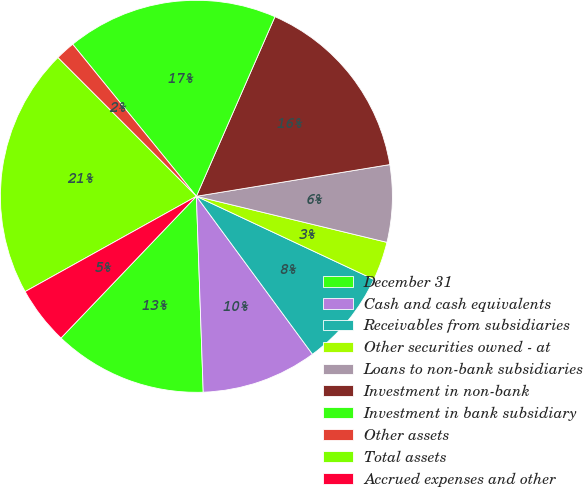Convert chart. <chart><loc_0><loc_0><loc_500><loc_500><pie_chart><fcel>December 31<fcel>Cash and cash equivalents<fcel>Receivables from subsidiaries<fcel>Other securities owned - at<fcel>Loans to non-bank subsidiaries<fcel>Investment in non-bank<fcel>Investment in bank subsidiary<fcel>Other assets<fcel>Total assets<fcel>Accrued expenses and other<nl><fcel>12.69%<fcel>9.53%<fcel>7.94%<fcel>3.2%<fcel>6.36%<fcel>15.85%<fcel>17.43%<fcel>1.62%<fcel>20.59%<fcel>4.78%<nl></chart> 